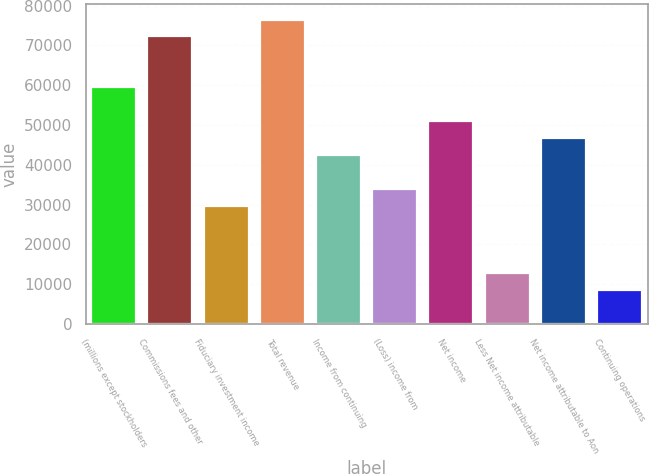Convert chart to OTSL. <chart><loc_0><loc_0><loc_500><loc_500><bar_chart><fcel>(millions except stockholders<fcel>Commissions fees and other<fcel>Fiduciary investment income<fcel>Total revenue<fcel>Income from continuing<fcel>(Loss) income from<fcel>Net income<fcel>Less Net income attributable<fcel>Net income attributable to Aon<fcel>Continuing operations<nl><fcel>59499.8<fcel>72249.6<fcel>29750.2<fcel>76499.5<fcel>42500<fcel>34000.1<fcel>50999.9<fcel>12750.4<fcel>46749.9<fcel>8500.48<nl></chart> 